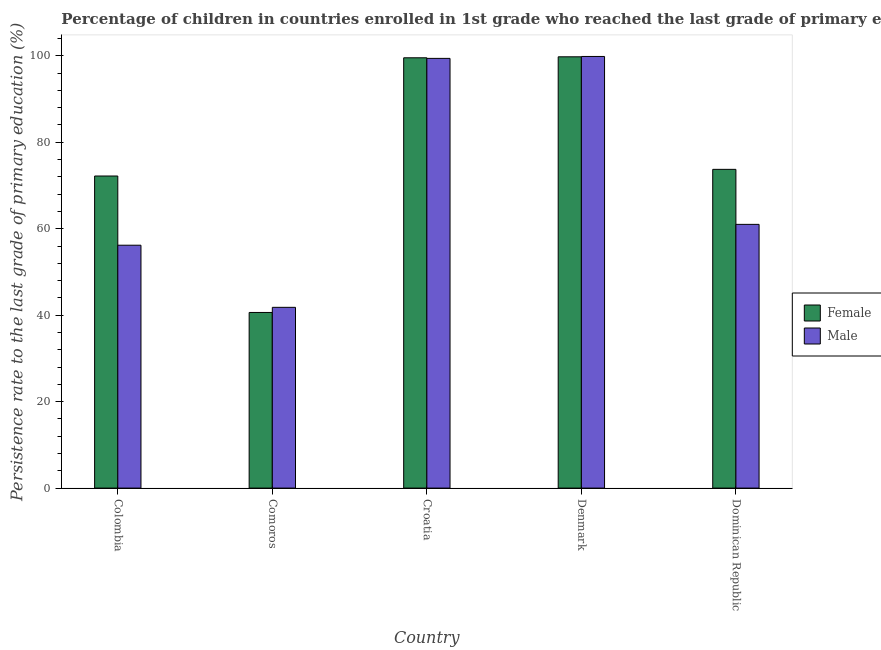How many groups of bars are there?
Offer a very short reply. 5. Are the number of bars on each tick of the X-axis equal?
Ensure brevity in your answer.  Yes. How many bars are there on the 2nd tick from the left?
Provide a short and direct response. 2. What is the label of the 3rd group of bars from the left?
Keep it short and to the point. Croatia. In how many cases, is the number of bars for a given country not equal to the number of legend labels?
Keep it short and to the point. 0. What is the persistence rate of female students in Croatia?
Your answer should be very brief. 99.54. Across all countries, what is the maximum persistence rate of female students?
Provide a short and direct response. 99.77. Across all countries, what is the minimum persistence rate of female students?
Your response must be concise. 40.63. In which country was the persistence rate of female students maximum?
Offer a very short reply. Denmark. In which country was the persistence rate of male students minimum?
Provide a short and direct response. Comoros. What is the total persistence rate of male students in the graph?
Offer a very short reply. 358.26. What is the difference between the persistence rate of male students in Colombia and that in Comoros?
Keep it short and to the point. 14.37. What is the difference between the persistence rate of female students in Denmark and the persistence rate of male students in Comoros?
Offer a terse response. 57.96. What is the average persistence rate of female students per country?
Give a very brief answer. 77.18. What is the difference between the persistence rate of male students and persistence rate of female students in Denmark?
Make the answer very short. 0.08. In how many countries, is the persistence rate of female students greater than 88 %?
Make the answer very short. 2. What is the ratio of the persistence rate of female students in Denmark to that in Dominican Republic?
Give a very brief answer. 1.35. Is the persistence rate of female students in Croatia less than that in Denmark?
Offer a terse response. Yes. Is the difference between the persistence rate of female students in Colombia and Denmark greater than the difference between the persistence rate of male students in Colombia and Denmark?
Provide a short and direct response. Yes. What is the difference between the highest and the second highest persistence rate of male students?
Provide a short and direct response. 0.45. What is the difference between the highest and the lowest persistence rate of male students?
Keep it short and to the point. 58.04. Is the sum of the persistence rate of male students in Comoros and Croatia greater than the maximum persistence rate of female students across all countries?
Offer a terse response. Yes. Are all the bars in the graph horizontal?
Provide a short and direct response. No. How many countries are there in the graph?
Offer a very short reply. 5. Are the values on the major ticks of Y-axis written in scientific E-notation?
Keep it short and to the point. No. How many legend labels are there?
Give a very brief answer. 2. How are the legend labels stacked?
Offer a very short reply. Vertical. What is the title of the graph?
Provide a short and direct response. Percentage of children in countries enrolled in 1st grade who reached the last grade of primary education. Does "Under-five" appear as one of the legend labels in the graph?
Offer a very short reply. No. What is the label or title of the X-axis?
Keep it short and to the point. Country. What is the label or title of the Y-axis?
Offer a terse response. Persistence rate to the last grade of primary education (%). What is the Persistence rate to the last grade of primary education (%) in Female in Colombia?
Ensure brevity in your answer.  72.2. What is the Persistence rate to the last grade of primary education (%) in Male in Colombia?
Make the answer very short. 56.19. What is the Persistence rate to the last grade of primary education (%) of Female in Comoros?
Your answer should be very brief. 40.63. What is the Persistence rate to the last grade of primary education (%) of Male in Comoros?
Make the answer very short. 41.81. What is the Persistence rate to the last grade of primary education (%) of Female in Croatia?
Your answer should be very brief. 99.54. What is the Persistence rate to the last grade of primary education (%) in Male in Croatia?
Ensure brevity in your answer.  99.41. What is the Persistence rate to the last grade of primary education (%) of Female in Denmark?
Your answer should be compact. 99.77. What is the Persistence rate to the last grade of primary education (%) of Male in Denmark?
Provide a short and direct response. 99.85. What is the Persistence rate to the last grade of primary education (%) in Female in Dominican Republic?
Provide a short and direct response. 73.74. What is the Persistence rate to the last grade of primary education (%) of Male in Dominican Republic?
Give a very brief answer. 61.01. Across all countries, what is the maximum Persistence rate to the last grade of primary education (%) of Female?
Your answer should be compact. 99.77. Across all countries, what is the maximum Persistence rate to the last grade of primary education (%) in Male?
Make the answer very short. 99.85. Across all countries, what is the minimum Persistence rate to the last grade of primary education (%) of Female?
Make the answer very short. 40.63. Across all countries, what is the minimum Persistence rate to the last grade of primary education (%) in Male?
Provide a succinct answer. 41.81. What is the total Persistence rate to the last grade of primary education (%) in Female in the graph?
Ensure brevity in your answer.  385.88. What is the total Persistence rate to the last grade of primary education (%) in Male in the graph?
Give a very brief answer. 358.26. What is the difference between the Persistence rate to the last grade of primary education (%) in Female in Colombia and that in Comoros?
Offer a very short reply. 31.57. What is the difference between the Persistence rate to the last grade of primary education (%) in Male in Colombia and that in Comoros?
Your response must be concise. 14.37. What is the difference between the Persistence rate to the last grade of primary education (%) of Female in Colombia and that in Croatia?
Provide a short and direct response. -27.35. What is the difference between the Persistence rate to the last grade of primary education (%) of Male in Colombia and that in Croatia?
Give a very brief answer. -43.22. What is the difference between the Persistence rate to the last grade of primary education (%) of Female in Colombia and that in Denmark?
Your answer should be compact. -27.57. What is the difference between the Persistence rate to the last grade of primary education (%) of Male in Colombia and that in Denmark?
Your response must be concise. -43.66. What is the difference between the Persistence rate to the last grade of primary education (%) in Female in Colombia and that in Dominican Republic?
Your answer should be very brief. -1.54. What is the difference between the Persistence rate to the last grade of primary education (%) in Male in Colombia and that in Dominican Republic?
Make the answer very short. -4.82. What is the difference between the Persistence rate to the last grade of primary education (%) of Female in Comoros and that in Croatia?
Make the answer very short. -58.91. What is the difference between the Persistence rate to the last grade of primary education (%) in Male in Comoros and that in Croatia?
Ensure brevity in your answer.  -57.59. What is the difference between the Persistence rate to the last grade of primary education (%) in Female in Comoros and that in Denmark?
Offer a terse response. -59.14. What is the difference between the Persistence rate to the last grade of primary education (%) in Male in Comoros and that in Denmark?
Your answer should be very brief. -58.04. What is the difference between the Persistence rate to the last grade of primary education (%) of Female in Comoros and that in Dominican Republic?
Offer a very short reply. -33.11. What is the difference between the Persistence rate to the last grade of primary education (%) of Male in Comoros and that in Dominican Republic?
Provide a succinct answer. -19.2. What is the difference between the Persistence rate to the last grade of primary education (%) of Female in Croatia and that in Denmark?
Provide a succinct answer. -0.23. What is the difference between the Persistence rate to the last grade of primary education (%) in Male in Croatia and that in Denmark?
Your answer should be very brief. -0.45. What is the difference between the Persistence rate to the last grade of primary education (%) in Female in Croatia and that in Dominican Republic?
Offer a very short reply. 25.81. What is the difference between the Persistence rate to the last grade of primary education (%) in Male in Croatia and that in Dominican Republic?
Make the answer very short. 38.4. What is the difference between the Persistence rate to the last grade of primary education (%) of Female in Denmark and that in Dominican Republic?
Offer a very short reply. 26.04. What is the difference between the Persistence rate to the last grade of primary education (%) of Male in Denmark and that in Dominican Republic?
Your answer should be compact. 38.84. What is the difference between the Persistence rate to the last grade of primary education (%) in Female in Colombia and the Persistence rate to the last grade of primary education (%) in Male in Comoros?
Offer a terse response. 30.38. What is the difference between the Persistence rate to the last grade of primary education (%) of Female in Colombia and the Persistence rate to the last grade of primary education (%) of Male in Croatia?
Offer a very short reply. -27.21. What is the difference between the Persistence rate to the last grade of primary education (%) of Female in Colombia and the Persistence rate to the last grade of primary education (%) of Male in Denmark?
Your answer should be very brief. -27.65. What is the difference between the Persistence rate to the last grade of primary education (%) in Female in Colombia and the Persistence rate to the last grade of primary education (%) in Male in Dominican Republic?
Ensure brevity in your answer.  11.19. What is the difference between the Persistence rate to the last grade of primary education (%) in Female in Comoros and the Persistence rate to the last grade of primary education (%) in Male in Croatia?
Offer a very short reply. -58.78. What is the difference between the Persistence rate to the last grade of primary education (%) of Female in Comoros and the Persistence rate to the last grade of primary education (%) of Male in Denmark?
Your answer should be compact. -59.22. What is the difference between the Persistence rate to the last grade of primary education (%) of Female in Comoros and the Persistence rate to the last grade of primary education (%) of Male in Dominican Republic?
Ensure brevity in your answer.  -20.38. What is the difference between the Persistence rate to the last grade of primary education (%) of Female in Croatia and the Persistence rate to the last grade of primary education (%) of Male in Denmark?
Offer a very short reply. -0.31. What is the difference between the Persistence rate to the last grade of primary education (%) in Female in Croatia and the Persistence rate to the last grade of primary education (%) in Male in Dominican Republic?
Ensure brevity in your answer.  38.53. What is the difference between the Persistence rate to the last grade of primary education (%) in Female in Denmark and the Persistence rate to the last grade of primary education (%) in Male in Dominican Republic?
Keep it short and to the point. 38.76. What is the average Persistence rate to the last grade of primary education (%) of Female per country?
Your answer should be very brief. 77.18. What is the average Persistence rate to the last grade of primary education (%) of Male per country?
Provide a succinct answer. 71.65. What is the difference between the Persistence rate to the last grade of primary education (%) of Female and Persistence rate to the last grade of primary education (%) of Male in Colombia?
Provide a succinct answer. 16.01. What is the difference between the Persistence rate to the last grade of primary education (%) of Female and Persistence rate to the last grade of primary education (%) of Male in Comoros?
Offer a terse response. -1.18. What is the difference between the Persistence rate to the last grade of primary education (%) of Female and Persistence rate to the last grade of primary education (%) of Male in Croatia?
Ensure brevity in your answer.  0.14. What is the difference between the Persistence rate to the last grade of primary education (%) of Female and Persistence rate to the last grade of primary education (%) of Male in Denmark?
Make the answer very short. -0.08. What is the difference between the Persistence rate to the last grade of primary education (%) of Female and Persistence rate to the last grade of primary education (%) of Male in Dominican Republic?
Provide a short and direct response. 12.73. What is the ratio of the Persistence rate to the last grade of primary education (%) of Female in Colombia to that in Comoros?
Provide a succinct answer. 1.78. What is the ratio of the Persistence rate to the last grade of primary education (%) in Male in Colombia to that in Comoros?
Offer a very short reply. 1.34. What is the ratio of the Persistence rate to the last grade of primary education (%) of Female in Colombia to that in Croatia?
Provide a short and direct response. 0.73. What is the ratio of the Persistence rate to the last grade of primary education (%) of Male in Colombia to that in Croatia?
Provide a succinct answer. 0.57. What is the ratio of the Persistence rate to the last grade of primary education (%) of Female in Colombia to that in Denmark?
Ensure brevity in your answer.  0.72. What is the ratio of the Persistence rate to the last grade of primary education (%) in Male in Colombia to that in Denmark?
Keep it short and to the point. 0.56. What is the ratio of the Persistence rate to the last grade of primary education (%) of Female in Colombia to that in Dominican Republic?
Offer a very short reply. 0.98. What is the ratio of the Persistence rate to the last grade of primary education (%) of Male in Colombia to that in Dominican Republic?
Offer a very short reply. 0.92. What is the ratio of the Persistence rate to the last grade of primary education (%) of Female in Comoros to that in Croatia?
Keep it short and to the point. 0.41. What is the ratio of the Persistence rate to the last grade of primary education (%) in Male in Comoros to that in Croatia?
Ensure brevity in your answer.  0.42. What is the ratio of the Persistence rate to the last grade of primary education (%) in Female in Comoros to that in Denmark?
Provide a short and direct response. 0.41. What is the ratio of the Persistence rate to the last grade of primary education (%) in Male in Comoros to that in Denmark?
Your answer should be compact. 0.42. What is the ratio of the Persistence rate to the last grade of primary education (%) in Female in Comoros to that in Dominican Republic?
Keep it short and to the point. 0.55. What is the ratio of the Persistence rate to the last grade of primary education (%) in Male in Comoros to that in Dominican Republic?
Keep it short and to the point. 0.69. What is the ratio of the Persistence rate to the last grade of primary education (%) in Female in Croatia to that in Denmark?
Offer a very short reply. 1. What is the ratio of the Persistence rate to the last grade of primary education (%) in Female in Croatia to that in Dominican Republic?
Your answer should be very brief. 1.35. What is the ratio of the Persistence rate to the last grade of primary education (%) of Male in Croatia to that in Dominican Republic?
Provide a short and direct response. 1.63. What is the ratio of the Persistence rate to the last grade of primary education (%) of Female in Denmark to that in Dominican Republic?
Provide a short and direct response. 1.35. What is the ratio of the Persistence rate to the last grade of primary education (%) in Male in Denmark to that in Dominican Republic?
Your response must be concise. 1.64. What is the difference between the highest and the second highest Persistence rate to the last grade of primary education (%) of Female?
Make the answer very short. 0.23. What is the difference between the highest and the second highest Persistence rate to the last grade of primary education (%) of Male?
Provide a succinct answer. 0.45. What is the difference between the highest and the lowest Persistence rate to the last grade of primary education (%) in Female?
Give a very brief answer. 59.14. What is the difference between the highest and the lowest Persistence rate to the last grade of primary education (%) in Male?
Give a very brief answer. 58.04. 